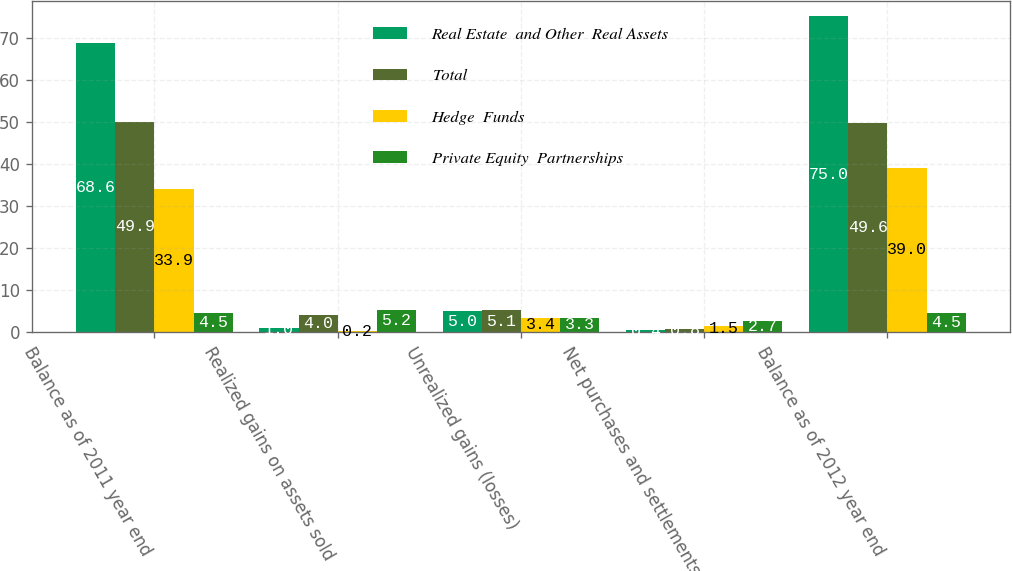Convert chart to OTSL. <chart><loc_0><loc_0><loc_500><loc_500><stacked_bar_chart><ecel><fcel>Balance as of 2011 year end<fcel>Realized gains on assets sold<fcel>Unrealized gains (losses)<fcel>Net purchases and settlements<fcel>Balance as of 2012 year end<nl><fcel>Real Estate  and Other  Real Assets<fcel>68.6<fcel>1<fcel>5<fcel>0.4<fcel>75<nl><fcel>Total<fcel>49.9<fcel>4<fcel>5.1<fcel>0.8<fcel>49.6<nl><fcel>Hedge  Funds<fcel>33.9<fcel>0.2<fcel>3.4<fcel>1.5<fcel>39<nl><fcel>Private Equity  Partnerships<fcel>4.5<fcel>5.2<fcel>3.3<fcel>2.7<fcel>4.5<nl></chart> 